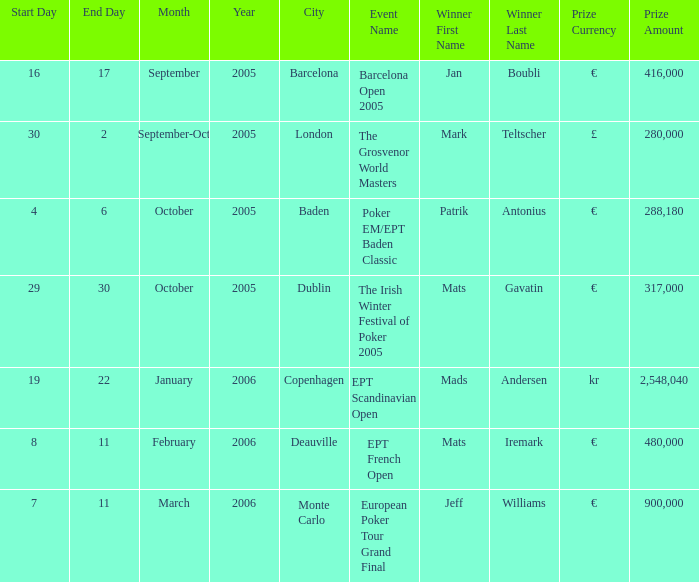Which incident resulted in mark teltscher's victory? The Grosvenor World Masters. 